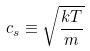Convert formula to latex. <formula><loc_0><loc_0><loc_500><loc_500>c _ { s } \equiv \sqrt { \frac { k T } { m } }</formula> 